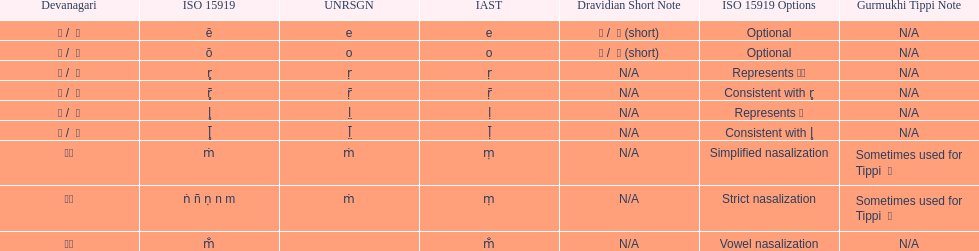This table shows the difference between how many transliterations? 3. 